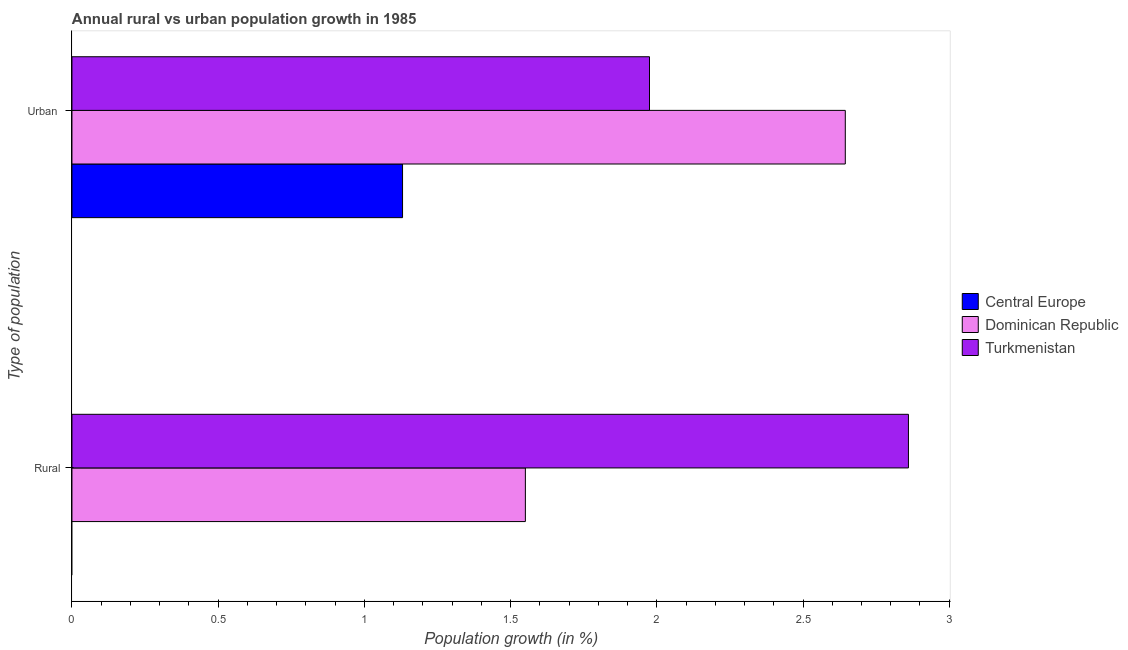Are the number of bars per tick equal to the number of legend labels?
Give a very brief answer. No. How many bars are there on the 1st tick from the top?
Keep it short and to the point. 3. What is the label of the 2nd group of bars from the top?
Your response must be concise. Rural. What is the rural population growth in Dominican Republic?
Offer a terse response. 1.55. Across all countries, what is the maximum urban population growth?
Provide a succinct answer. 2.64. Across all countries, what is the minimum urban population growth?
Provide a short and direct response. 1.13. In which country was the rural population growth maximum?
Your response must be concise. Turkmenistan. What is the total urban population growth in the graph?
Offer a very short reply. 5.75. What is the difference between the urban population growth in Dominican Republic and that in Turkmenistan?
Your response must be concise. 0.67. What is the difference between the urban population growth in Turkmenistan and the rural population growth in Dominican Republic?
Provide a succinct answer. 0.42. What is the average urban population growth per country?
Provide a short and direct response. 1.92. What is the difference between the rural population growth and urban population growth in Dominican Republic?
Make the answer very short. -1.09. What is the ratio of the urban population growth in Dominican Republic to that in Central Europe?
Keep it short and to the point. 2.34. In how many countries, is the urban population growth greater than the average urban population growth taken over all countries?
Keep it short and to the point. 2. Are the values on the major ticks of X-axis written in scientific E-notation?
Give a very brief answer. No. Does the graph contain grids?
Keep it short and to the point. No. What is the title of the graph?
Offer a terse response. Annual rural vs urban population growth in 1985. Does "Senegal" appear as one of the legend labels in the graph?
Keep it short and to the point. No. What is the label or title of the X-axis?
Provide a succinct answer. Population growth (in %). What is the label or title of the Y-axis?
Your response must be concise. Type of population. What is the Population growth (in %) in Central Europe in Rural?
Your answer should be very brief. 0. What is the Population growth (in %) in Dominican Republic in Rural?
Make the answer very short. 1.55. What is the Population growth (in %) in Turkmenistan in Rural?
Give a very brief answer. 2.86. What is the Population growth (in %) in Central Europe in Urban ?
Make the answer very short. 1.13. What is the Population growth (in %) of Dominican Republic in Urban ?
Provide a short and direct response. 2.64. What is the Population growth (in %) of Turkmenistan in Urban ?
Your response must be concise. 1.98. Across all Type of population, what is the maximum Population growth (in %) of Central Europe?
Keep it short and to the point. 1.13. Across all Type of population, what is the maximum Population growth (in %) of Dominican Republic?
Make the answer very short. 2.64. Across all Type of population, what is the maximum Population growth (in %) of Turkmenistan?
Offer a terse response. 2.86. Across all Type of population, what is the minimum Population growth (in %) in Dominican Republic?
Ensure brevity in your answer.  1.55. Across all Type of population, what is the minimum Population growth (in %) of Turkmenistan?
Offer a very short reply. 1.98. What is the total Population growth (in %) in Central Europe in the graph?
Your answer should be compact. 1.13. What is the total Population growth (in %) in Dominican Republic in the graph?
Ensure brevity in your answer.  4.2. What is the total Population growth (in %) in Turkmenistan in the graph?
Make the answer very short. 4.84. What is the difference between the Population growth (in %) of Dominican Republic in Rural and that in Urban ?
Your answer should be very brief. -1.09. What is the difference between the Population growth (in %) of Turkmenistan in Rural and that in Urban ?
Your response must be concise. 0.89. What is the difference between the Population growth (in %) in Dominican Republic in Rural and the Population growth (in %) in Turkmenistan in Urban ?
Offer a very short reply. -0.42. What is the average Population growth (in %) in Central Europe per Type of population?
Ensure brevity in your answer.  0.57. What is the average Population growth (in %) in Dominican Republic per Type of population?
Give a very brief answer. 2.1. What is the average Population growth (in %) in Turkmenistan per Type of population?
Offer a terse response. 2.42. What is the difference between the Population growth (in %) of Dominican Republic and Population growth (in %) of Turkmenistan in Rural?
Offer a terse response. -1.31. What is the difference between the Population growth (in %) in Central Europe and Population growth (in %) in Dominican Republic in Urban ?
Offer a terse response. -1.51. What is the difference between the Population growth (in %) of Central Europe and Population growth (in %) of Turkmenistan in Urban ?
Provide a short and direct response. -0.84. What is the difference between the Population growth (in %) of Dominican Republic and Population growth (in %) of Turkmenistan in Urban ?
Provide a short and direct response. 0.67. What is the ratio of the Population growth (in %) of Dominican Republic in Rural to that in Urban ?
Ensure brevity in your answer.  0.59. What is the ratio of the Population growth (in %) of Turkmenistan in Rural to that in Urban ?
Provide a succinct answer. 1.45. What is the difference between the highest and the second highest Population growth (in %) of Dominican Republic?
Your answer should be very brief. 1.09. What is the difference between the highest and the second highest Population growth (in %) in Turkmenistan?
Your response must be concise. 0.89. What is the difference between the highest and the lowest Population growth (in %) of Central Europe?
Offer a terse response. 1.13. What is the difference between the highest and the lowest Population growth (in %) in Dominican Republic?
Provide a succinct answer. 1.09. What is the difference between the highest and the lowest Population growth (in %) in Turkmenistan?
Give a very brief answer. 0.89. 